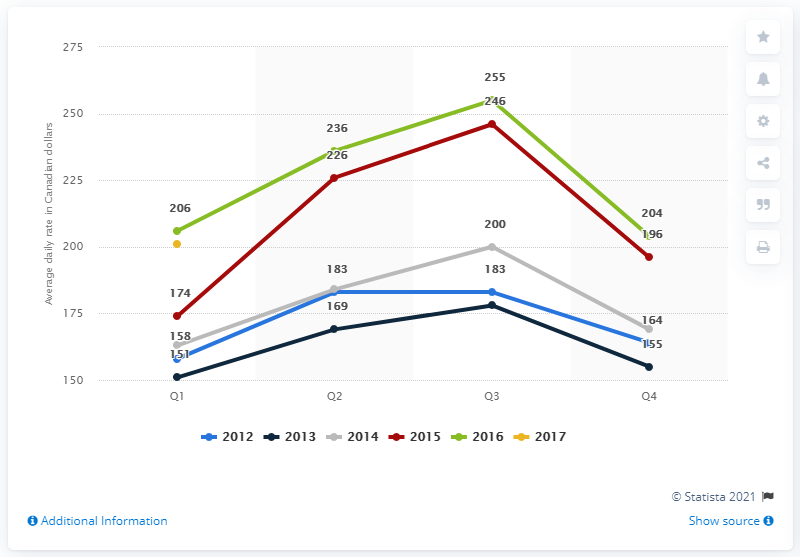List a handful of essential elements in this visual. The average daily rate of hotels in Vancouver, Canada, during the first quarter of 2017 was approximately $201. 